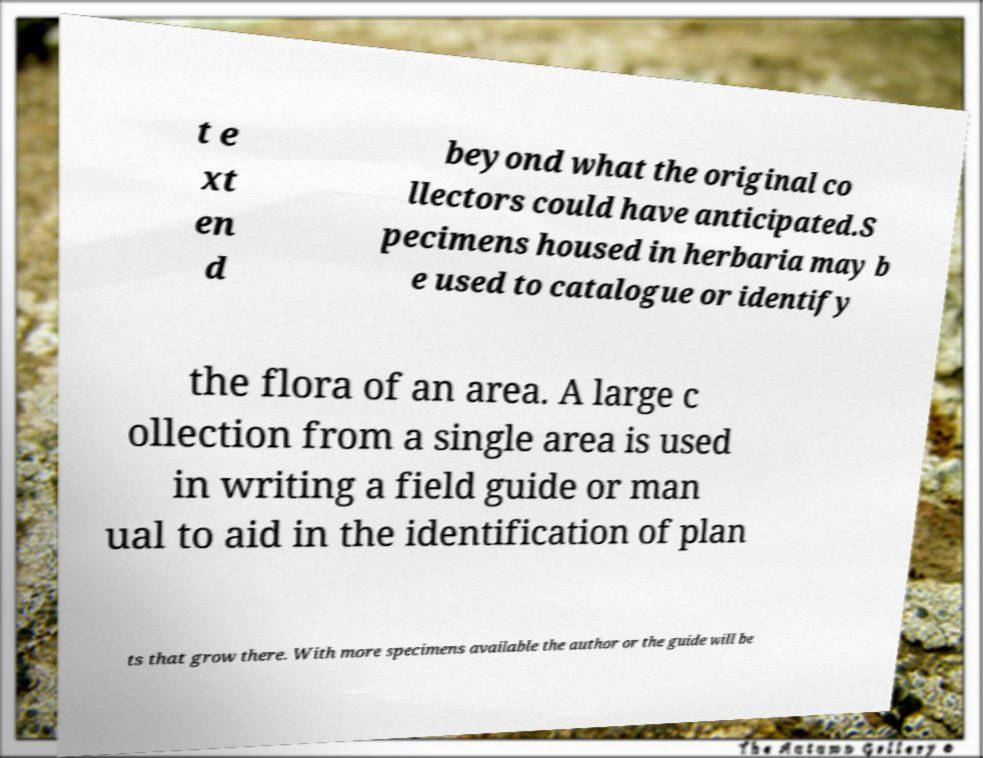Can you read and provide the text displayed in the image?This photo seems to have some interesting text. Can you extract and type it out for me? t e xt en d beyond what the original co llectors could have anticipated.S pecimens housed in herbaria may b e used to catalogue or identify the flora of an area. A large c ollection from a single area is used in writing a field guide or man ual to aid in the identification of plan ts that grow there. With more specimens available the author or the guide will be 